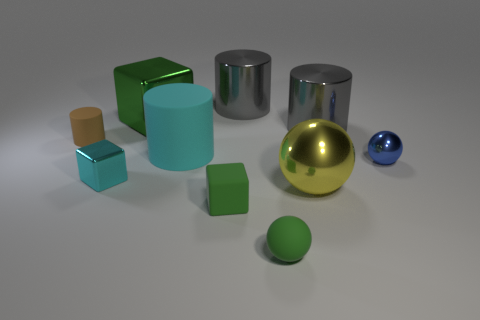Subtract all large cyan cylinders. How many cylinders are left? 3 Subtract all blue cylinders. How many green blocks are left? 2 Subtract 2 cylinders. How many cylinders are left? 2 Subtract all brown cylinders. How many cylinders are left? 3 Subtract all cylinders. How many objects are left? 6 Add 8 large gray cylinders. How many large gray cylinders exist? 10 Subtract 1 brown cylinders. How many objects are left? 9 Subtract all cyan cylinders. Subtract all brown balls. How many cylinders are left? 3 Subtract all tiny blue metal spheres. Subtract all yellow metallic spheres. How many objects are left? 8 Add 9 small brown cylinders. How many small brown cylinders are left? 10 